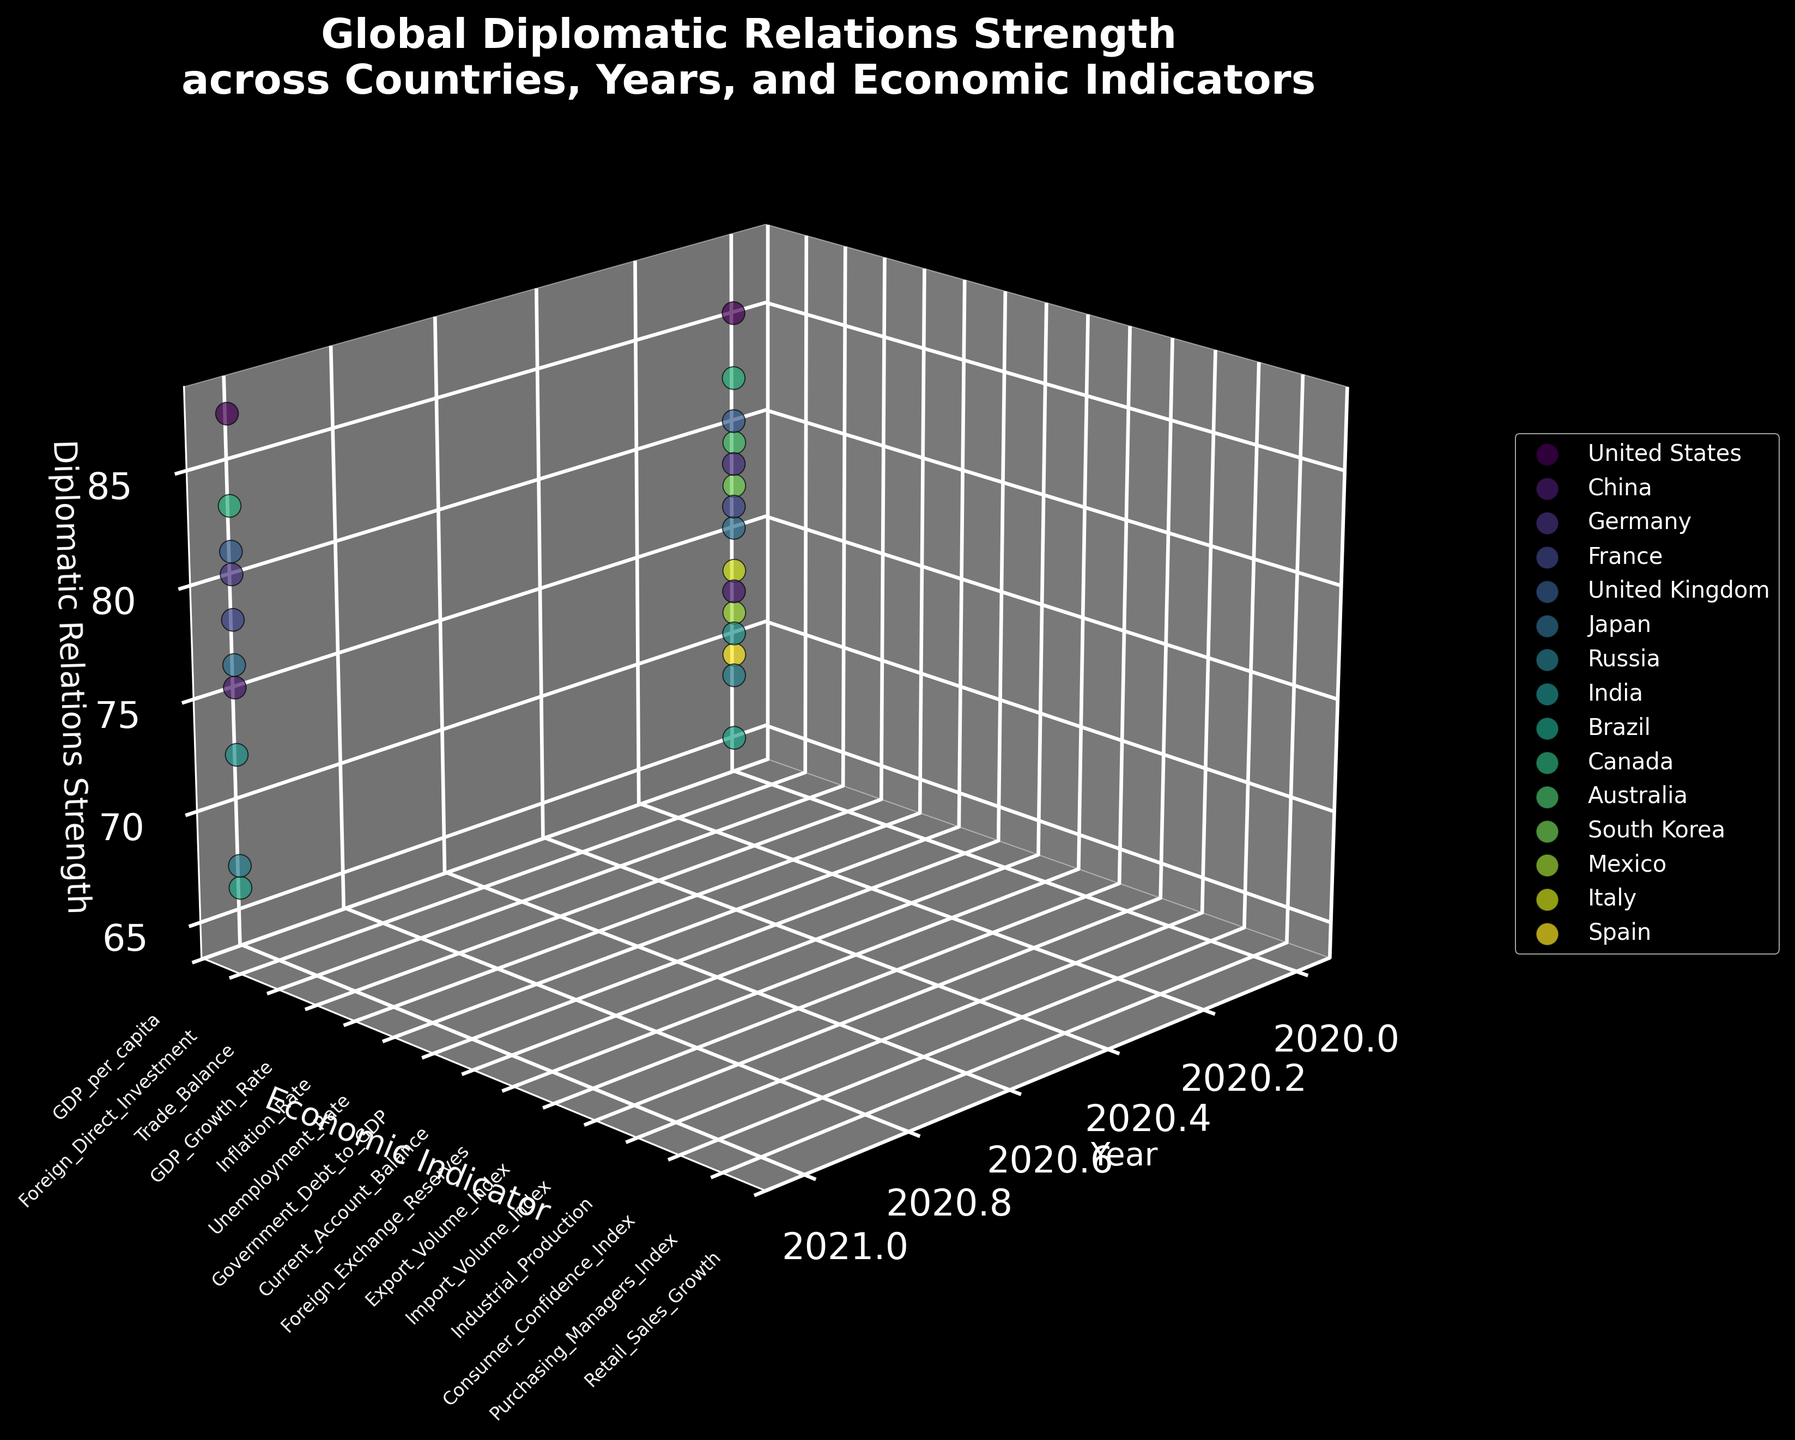How many countries are represented in the plot? Count the number of unique colors and labels in the legend, each representing a different country.
Answer: 14 What is the title of the figure? Read the bolded and prominent text at the top of the plot.
Answer: Global Diplomatic Relations Strength across Countries, Years, and Economic Indicators Which country had the highest Diplomatic Relations Strength in 2021? Identify the country data points for the year 2021, and find the one with the greatest height (z-axis value).
Answer: Canada Which economic indicator is represented by the "Consumer Confidence Index"? Look at the y-axis labels for the unique economic indicators, and identify the corresponding label.
Answer: Consumer Confidence Index What was the Diplomatic Relations Strength of Brazil in 2020? Locate Brazil's data point for the year 2020, and read the corresponding z-axis value.
Answer: 65 Which two countries had Diplomatic Relations Strength values of 75 in 2020, and how do their economic indicators differ? Identify the data points for 2020 where the z-axis is 75, find the corresponding countries, and compare their y-axis (economic indicator) labels.
Answer: Japan (Unemployment Rate) and India (Current Account Balance) What was the change in Diplomatic Relations Strength for the United Kingdom from 2020 to 2021? Locate the data points for the United Kingdom for 2020 and 2021, then find the difference between their z-axis values.
Answer: 1 How does the Diplomatic Relations Strength of the United States compare to China in 2021? Locate the United States and China data points for 2021, and compare their z-axis values to see which is higher.
Answer: United States > China Which economic indicator showed the highest Diplomatic Relations Strength in 2021, and which country does it belong to? Identify the highest data point on the z-axis for 2021, then match it to its y-axis label (economic indicator) and country.
Answer: GDP_per_capita, United States Among the data points for 2020, which economic indicator had the lowest Diplomatic Relations Strength, and which country does it belong to? Identify the lowest data point on the z-axis for 2020, then match it to its y-axis label (economic indicator) and country.
Answer: Foreign_Exchange_Reserves, Brazil 